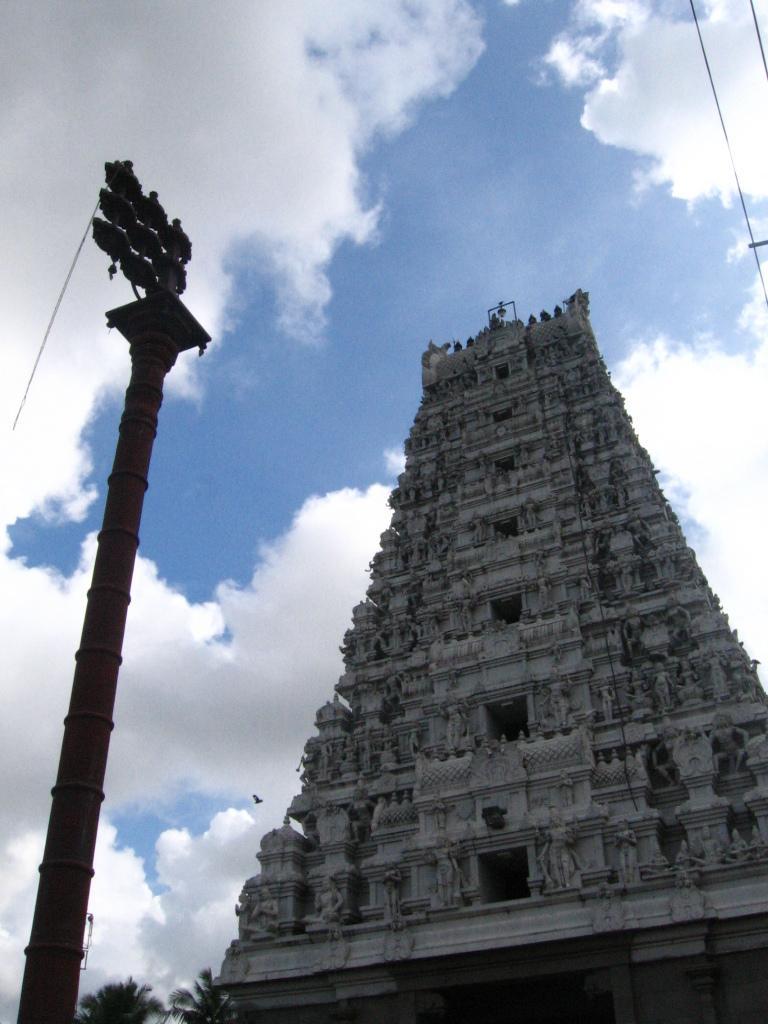How would you summarize this image in a sentence or two? On the right side of the image we can see a building with sculptures. In the left side of the image we can see a metal pole. At the bottom of the image we can see some trees. In the background, we can see a bird flying in the sky. 